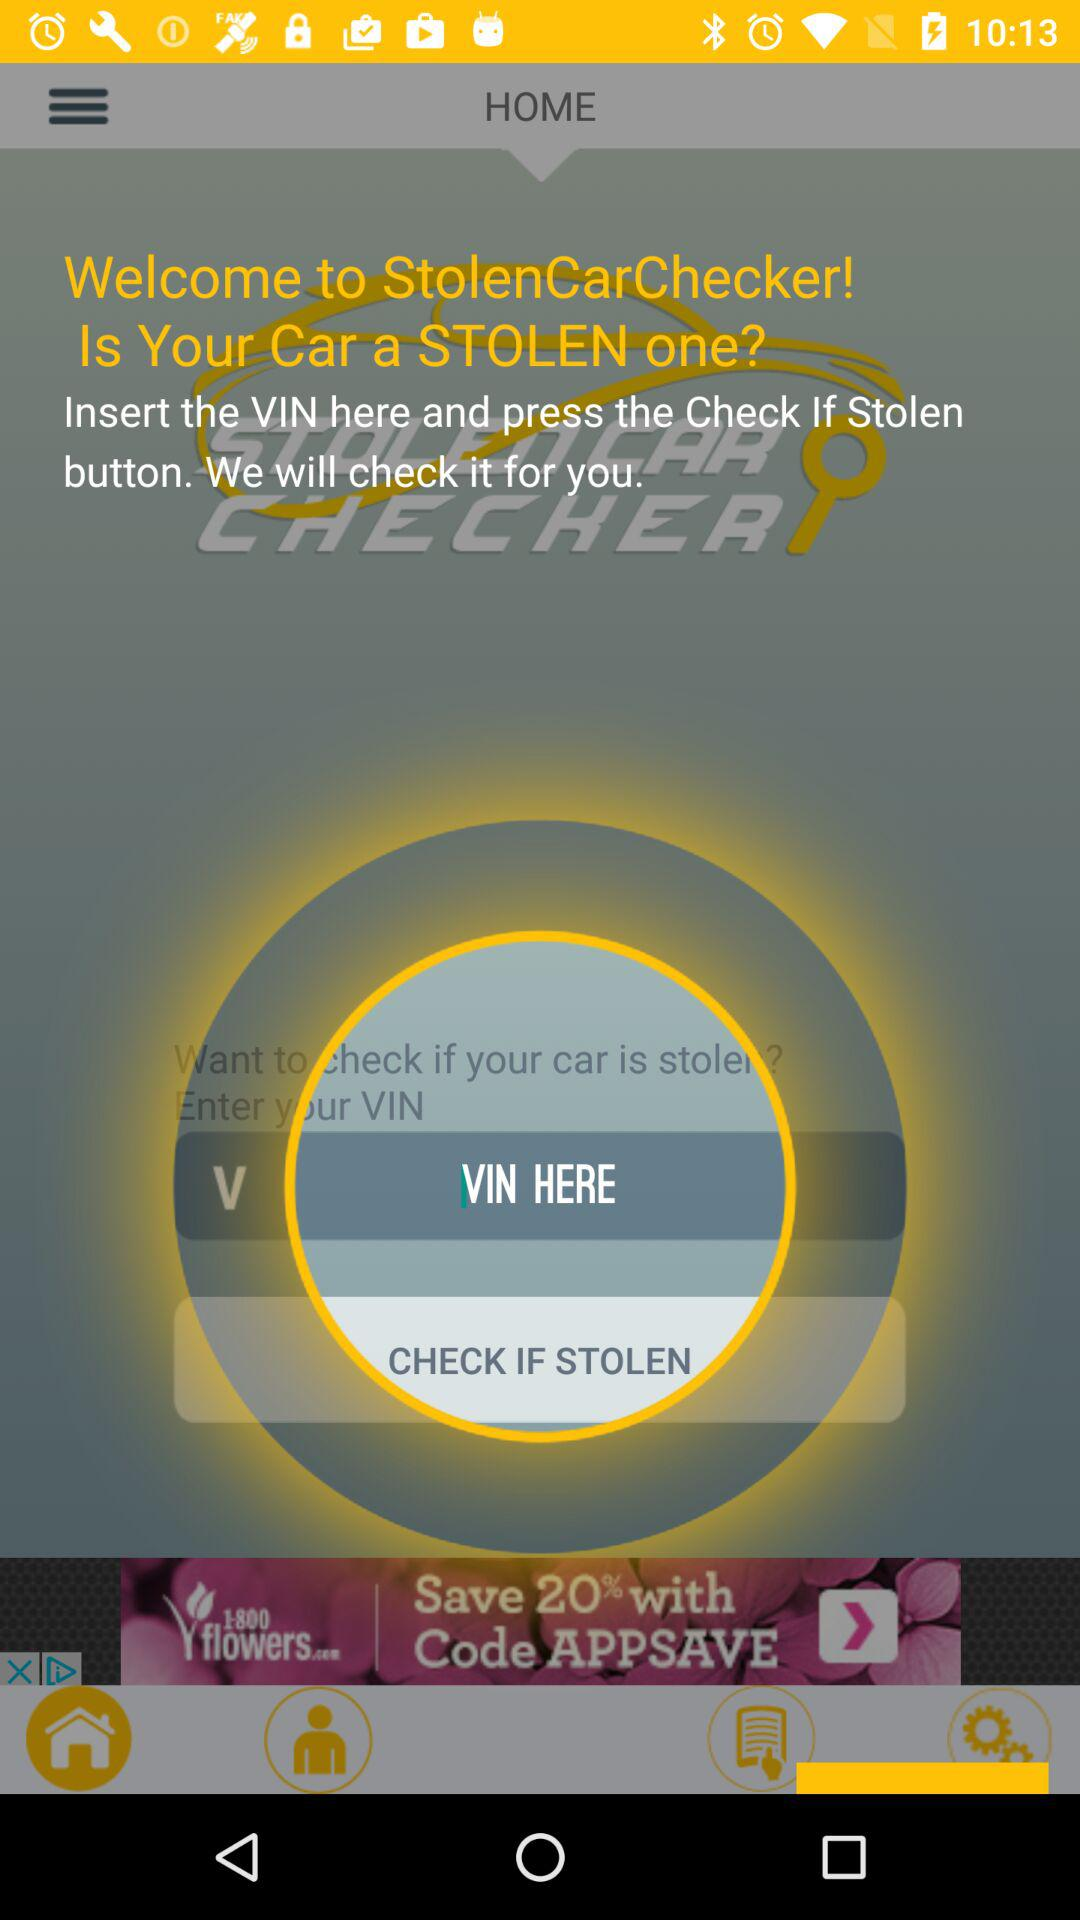What is the name of the application? The name of the application is "StolenCarChecker". 